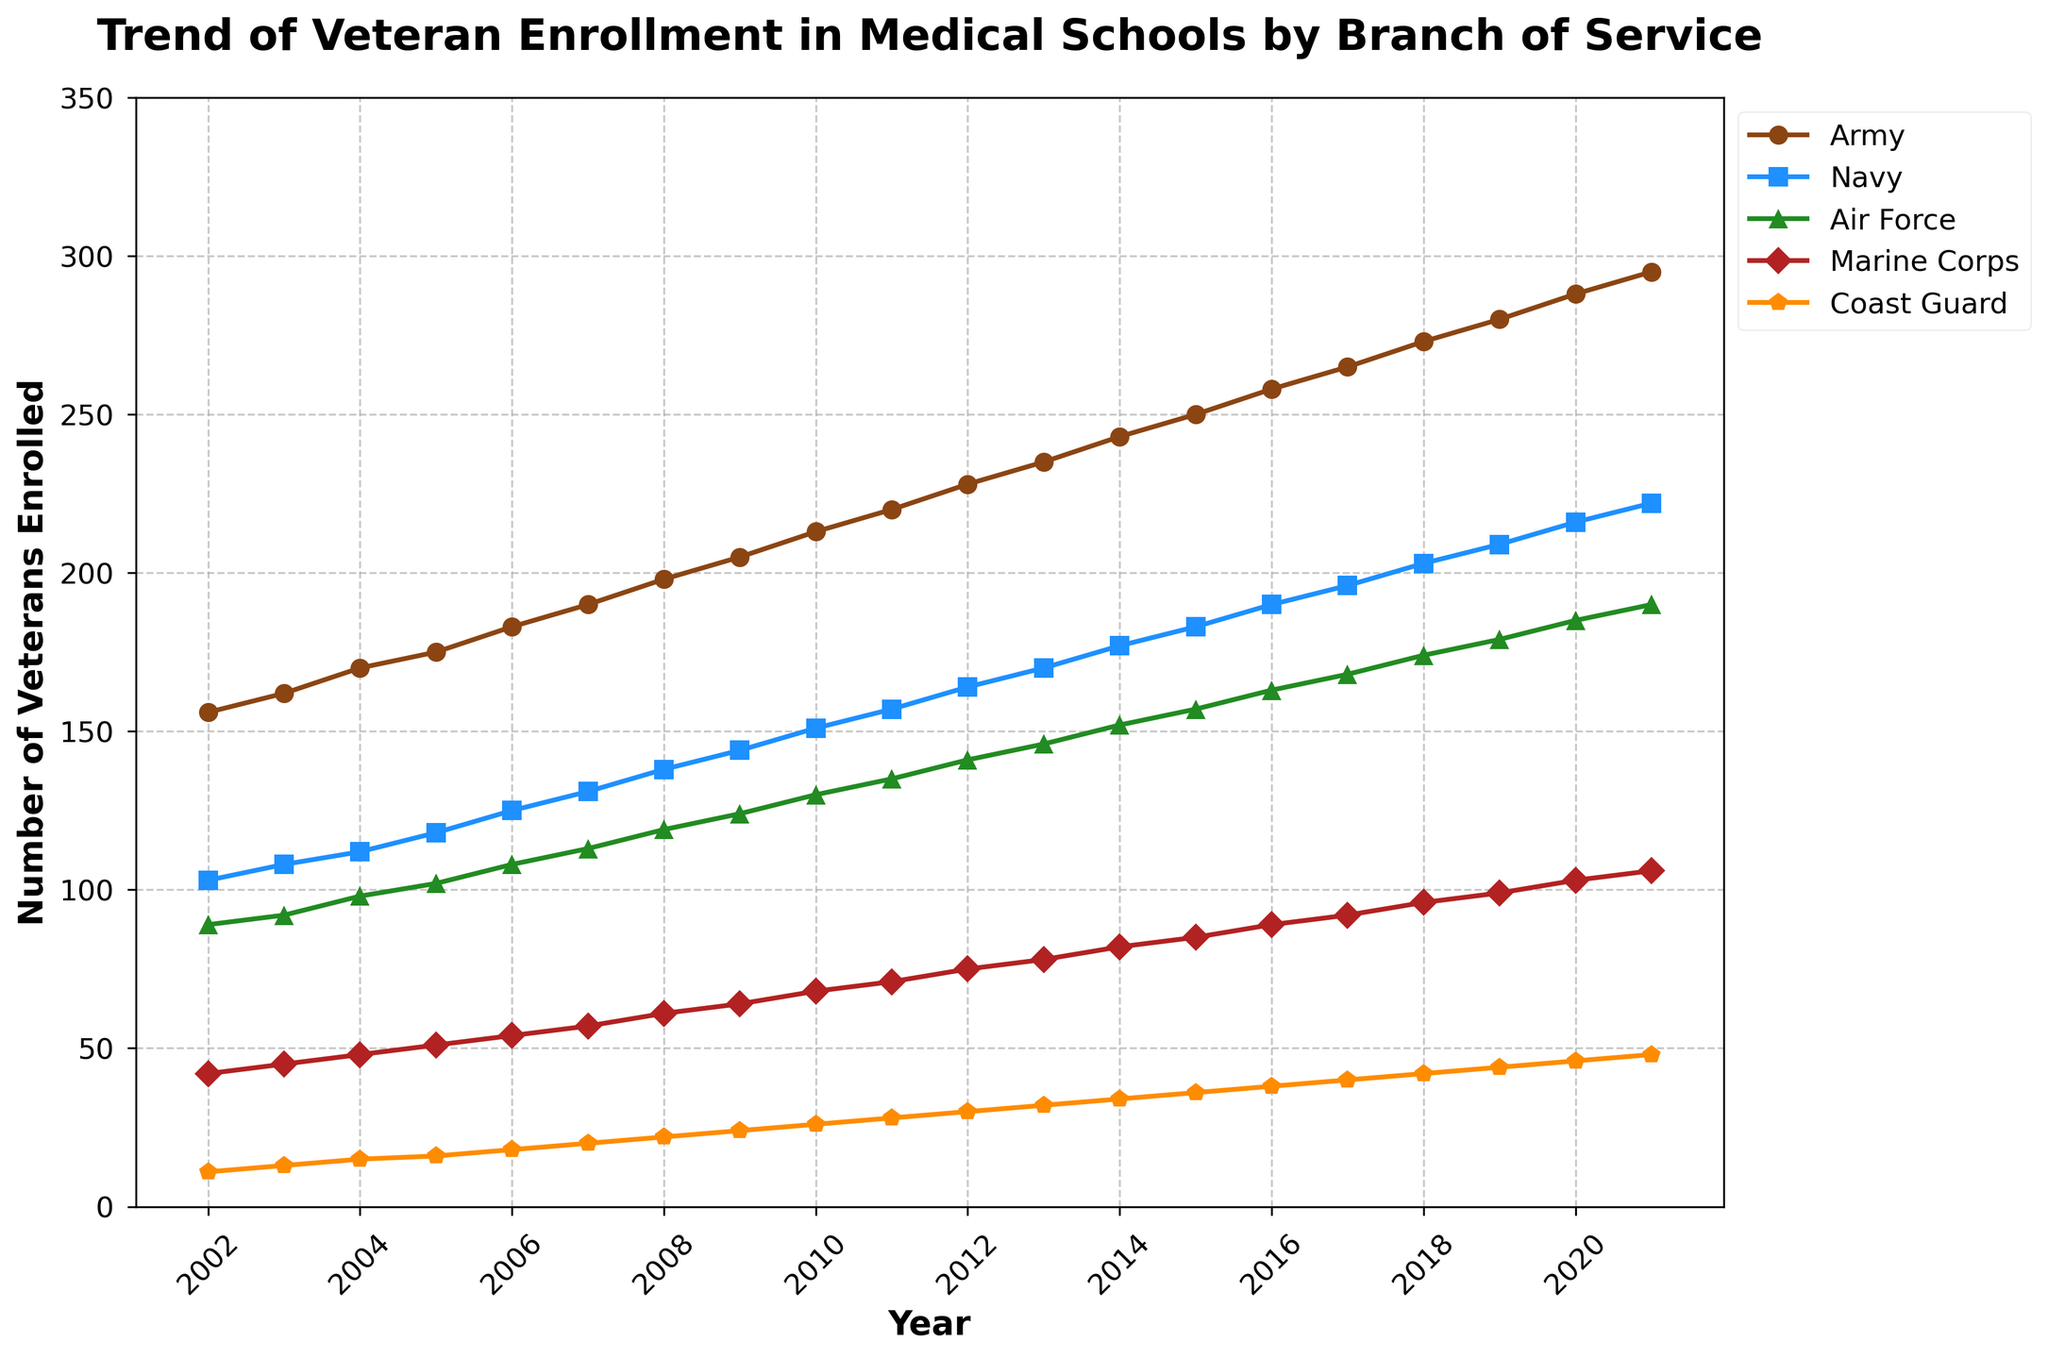What was the enrollment trend for Army veterans from 2002 to 2021? By examining the line representing Army veterans, we can see that it steadily rises over the years without any decreases, indicating a consistent increase in enrollment.
Answer: Steady increase Which branch had the highest enrollment in 2021? By comparing the endpoints of all the lines on the graph for the year 2021, we see that the Army has the highest value.
Answer: Army How much did Marine Corps enrollment increase from 2002 to 2021? The value in 2002 for the Marine Corps was 42, and it increased to 106 in 2021. The difference is 106 - 42 = 64.
Answer: 64 Which branch showed the most consistent growth over the period? Consistent growth can be evaluated by observing which line is the smoothest and has no dips or sudden increases. The Army's line shows a very steady and consistent upward trend throughout the years.
Answer: Army In which year did Navy veterans' enrollment surpass 150? By tracing the Navy's line, we see that it crossed the 150 mark between 2009 and 2010.
Answer: 2010 How do the enrollments of Air Force and Marine Corps veterans compare in 2015? In 2015, the enrollment was 157 for Air Force and 85 for Marine Corps. By comparing these two values, we see that Air Force's enrollment was much higher.
Answer: Air Force Did any branch's enrollment plateau or decrease during these years? By observing each line's trend from start to end, none of the branches show a plateau or decrease; all exhibit an increasing trend.
Answer: No What is the average number of Coast Guard veterans enrolled in 2002, 2011, and 2021? The enrollments are 11 (2002), 28 (2011), and 48 (2021). The average is calculated by (11 + 28 + 48) / 3 = 87 / 3 = 29.
Answer: 29 By what percentage did the Navy enrollment increase from 2002 to 2021? Initial value (2002) is 103 and final value (2021) is 222. The percentage increase is ((222 - 103) / 103) * 100 ≈ 115.53%.
Answer: 115.53% 